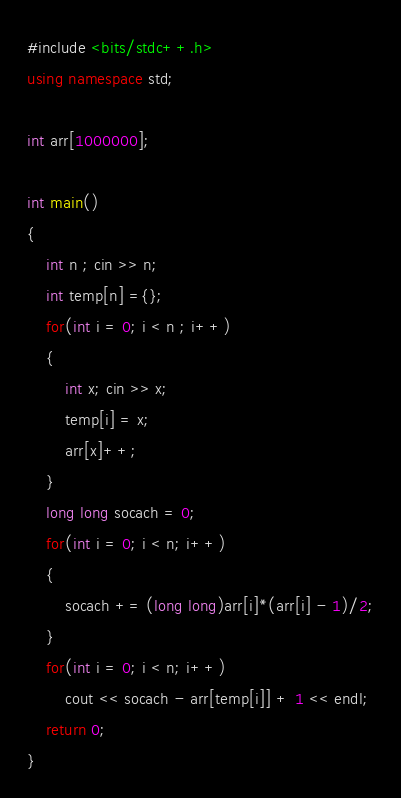Convert code to text. <code><loc_0><loc_0><loc_500><loc_500><_C++_>#include <bits/stdc++.h>
using namespace std;

int arr[1000000];

int main()
{
	int n ; cin >> n;
	int temp[n] ={};
	for(int i = 0; i < n ; i++)
	{
		int x; cin >> x;
		temp[i] = x;
		arr[x]++;
	}
	long long socach = 0;
	for(int i = 0; i < n; i++)
	{
		socach += (long long)arr[i]*(arr[i] - 1)/2;
	}
	for(int i = 0; i < n; i++)
		cout << socach - arr[temp[i]] + 1 << endl;
	return 0;
}</code> 